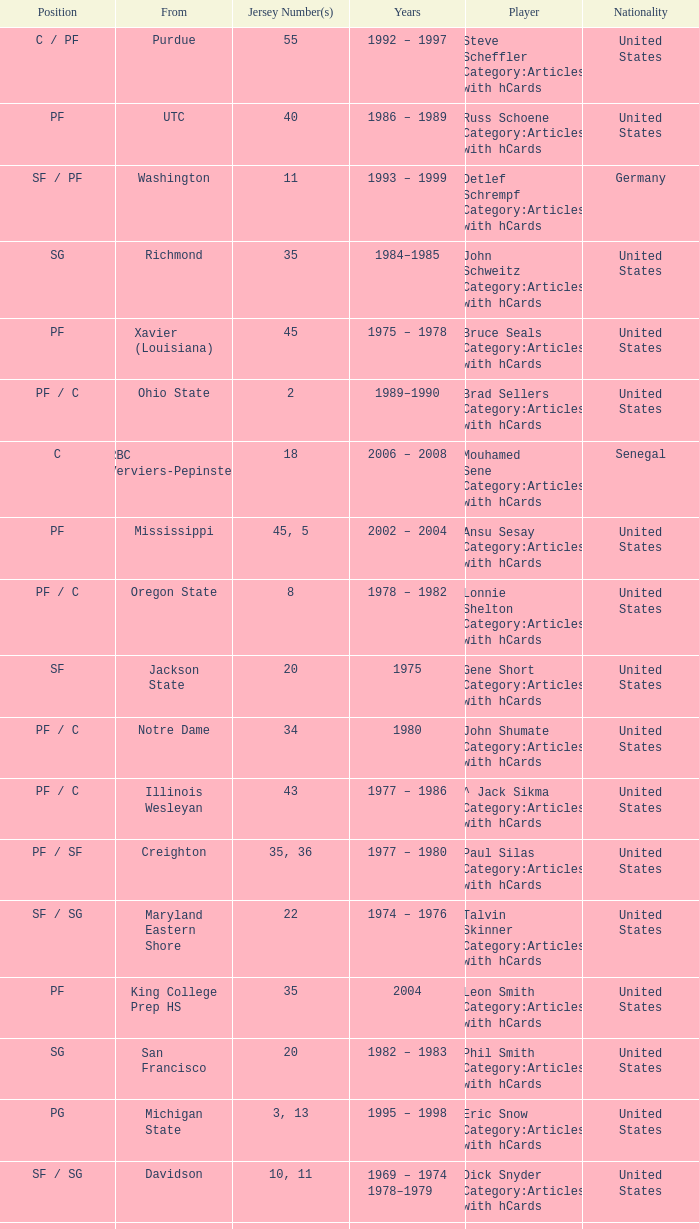What nationality is the player from Oregon State? United States. 